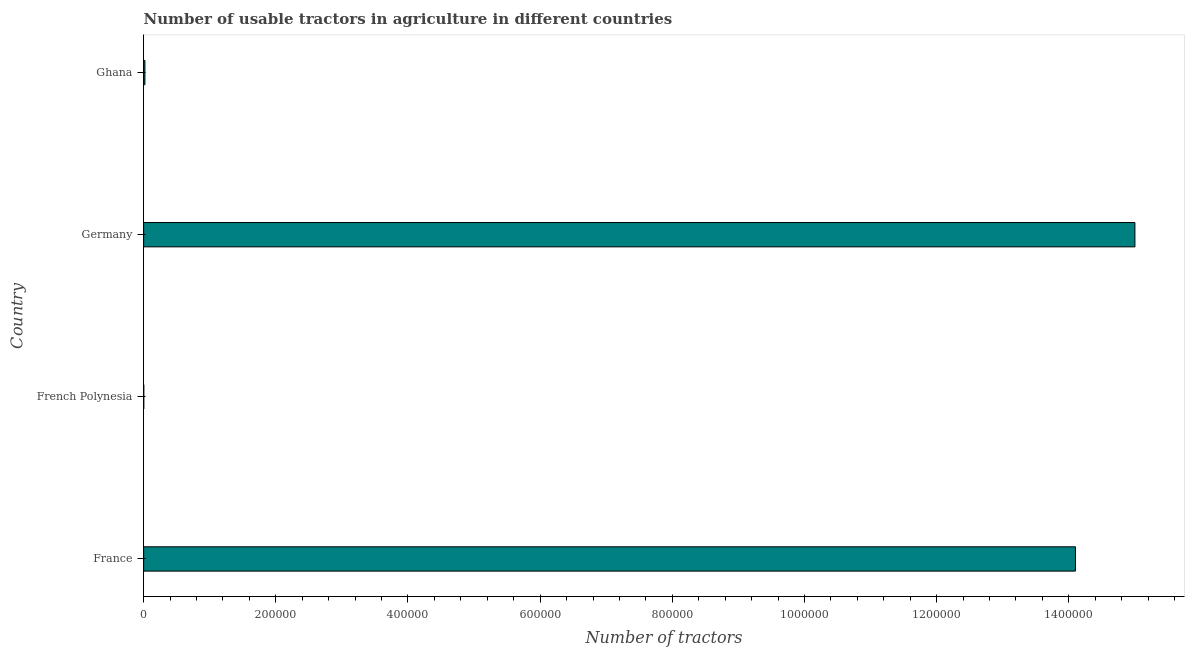Does the graph contain any zero values?
Give a very brief answer. No. What is the title of the graph?
Keep it short and to the point. Number of usable tractors in agriculture in different countries. What is the label or title of the X-axis?
Offer a very short reply. Number of tractors. What is the number of tractors in Germany?
Make the answer very short. 1.50e+06. Across all countries, what is the maximum number of tractors?
Your answer should be compact. 1.50e+06. Across all countries, what is the minimum number of tractors?
Keep it short and to the point. 210. In which country was the number of tractors maximum?
Your response must be concise. Germany. In which country was the number of tractors minimum?
Make the answer very short. French Polynesia. What is the sum of the number of tractors?
Make the answer very short. 2.91e+06. What is the difference between the number of tractors in France and Ghana?
Provide a short and direct response. 1.41e+06. What is the average number of tractors per country?
Give a very brief answer. 7.28e+05. What is the median number of tractors?
Your response must be concise. 7.06e+05. In how many countries, is the number of tractors greater than 720000 ?
Your response must be concise. 2. What is the difference between the highest and the second highest number of tractors?
Provide a short and direct response. 9.00e+04. Is the sum of the number of tractors in French Polynesia and Germany greater than the maximum number of tractors across all countries?
Offer a terse response. Yes. What is the difference between the highest and the lowest number of tractors?
Offer a very short reply. 1.50e+06. In how many countries, is the number of tractors greater than the average number of tractors taken over all countries?
Offer a very short reply. 2. What is the Number of tractors in France?
Ensure brevity in your answer.  1.41e+06. What is the Number of tractors of French Polynesia?
Offer a very short reply. 210. What is the Number of tractors in Germany?
Offer a terse response. 1.50e+06. What is the Number of tractors of Ghana?
Your answer should be compact. 1916. What is the difference between the Number of tractors in France and French Polynesia?
Make the answer very short. 1.41e+06. What is the difference between the Number of tractors in France and Germany?
Your answer should be compact. -9.00e+04. What is the difference between the Number of tractors in France and Ghana?
Give a very brief answer. 1.41e+06. What is the difference between the Number of tractors in French Polynesia and Germany?
Keep it short and to the point. -1.50e+06. What is the difference between the Number of tractors in French Polynesia and Ghana?
Make the answer very short. -1706. What is the difference between the Number of tractors in Germany and Ghana?
Your response must be concise. 1.50e+06. What is the ratio of the Number of tractors in France to that in French Polynesia?
Ensure brevity in your answer.  6714.29. What is the ratio of the Number of tractors in France to that in Ghana?
Give a very brief answer. 735.91. What is the ratio of the Number of tractors in French Polynesia to that in Germany?
Offer a very short reply. 0. What is the ratio of the Number of tractors in French Polynesia to that in Ghana?
Your answer should be compact. 0.11. What is the ratio of the Number of tractors in Germany to that in Ghana?
Give a very brief answer. 782.88. 